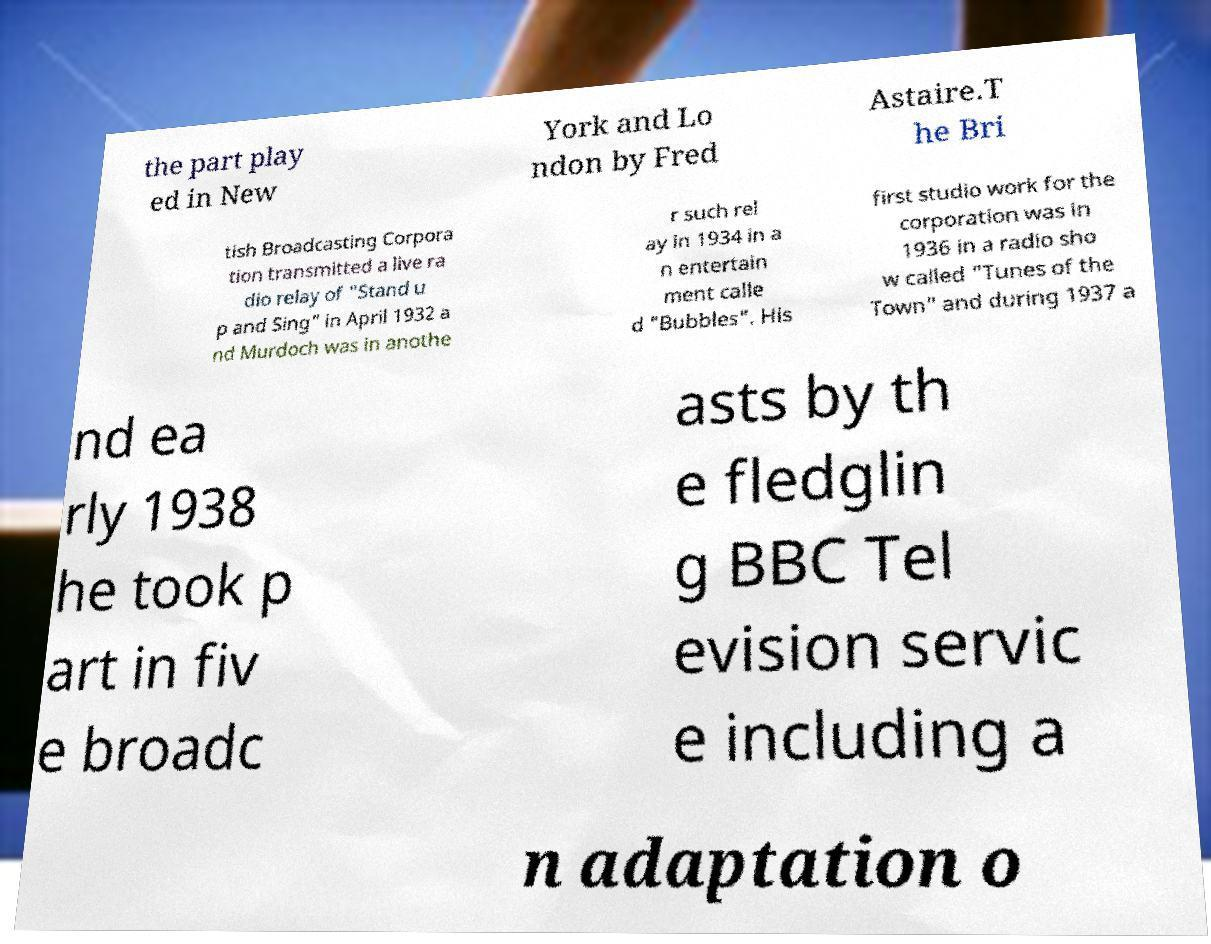For documentation purposes, I need the text within this image transcribed. Could you provide that? the part play ed in New York and Lo ndon by Fred Astaire.T he Bri tish Broadcasting Corpora tion transmitted a live ra dio relay of "Stand u p and Sing" in April 1932 a nd Murdoch was in anothe r such rel ay in 1934 in a n entertain ment calle d "Bubbles". His first studio work for the corporation was in 1936 in a radio sho w called "Tunes of the Town" and during 1937 a nd ea rly 1938 he took p art in fiv e broadc asts by th e fledglin g BBC Tel evision servic e including a n adaptation o 